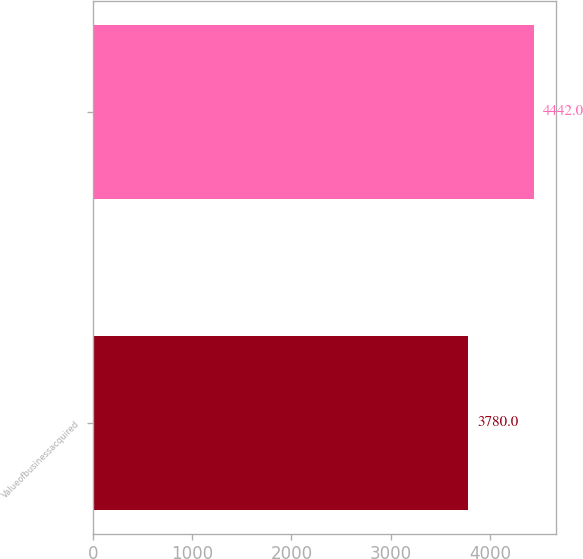Convert chart. <chart><loc_0><loc_0><loc_500><loc_500><bar_chart><fcel>Valueofbusinessacquired<fcel>Unnamed: 1<nl><fcel>3780<fcel>4442<nl></chart> 